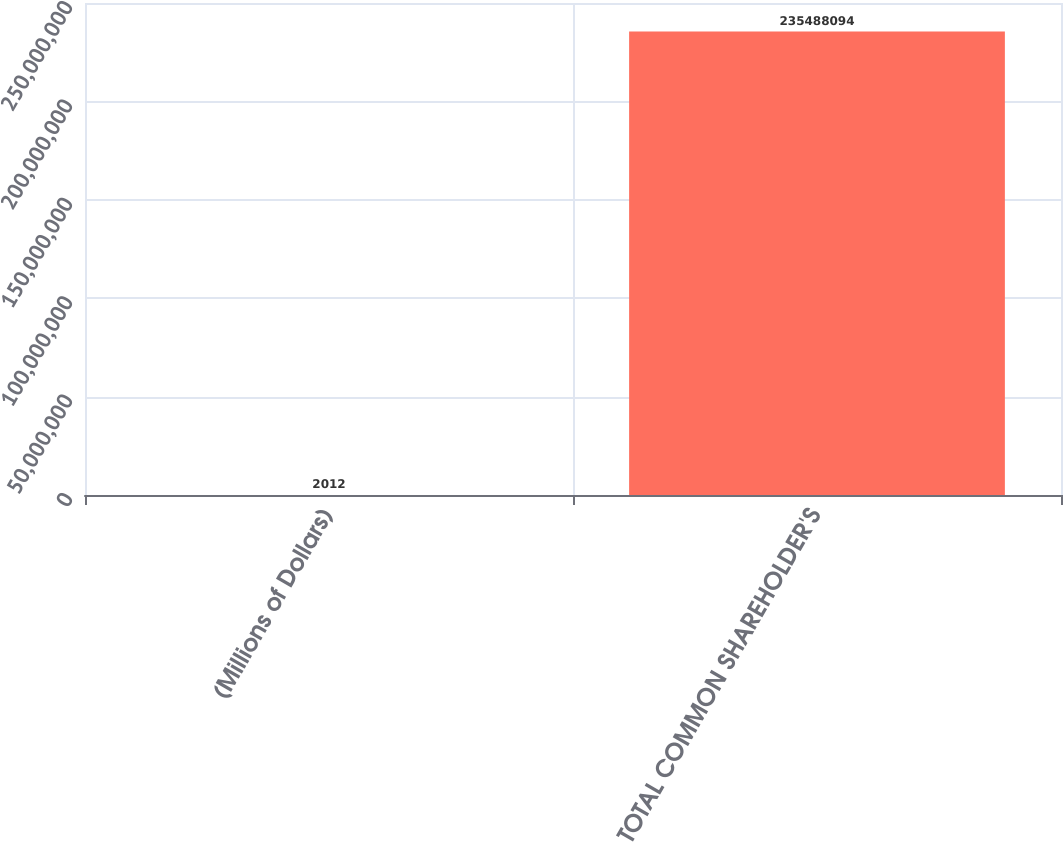Convert chart to OTSL. <chart><loc_0><loc_0><loc_500><loc_500><bar_chart><fcel>(Millions of Dollars)<fcel>TOTAL COMMON SHAREHOLDER'S<nl><fcel>2012<fcel>2.35488e+08<nl></chart> 